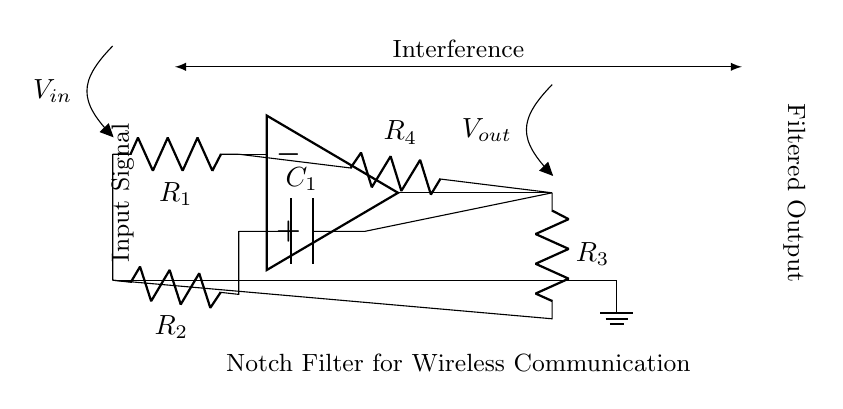What is the type of this filter? The circuit is specified as a Notch Filter, which is indicated in the diagram label. Its purpose is to eliminate particular frequencies of interference.
Answer: Notch Filter How many resistors are in the circuit? By counting the components in the diagram, there are four resistors labeled R1, R2, R3, and R4.
Answer: Four What is the function of the operational amplifier? The operational amplifier amplifies the input signal and helps in creating the required filter characteristics to remove unwanted noise.
Answer: Amplification What does C1 represent? C1 is labeled as a capacitor in the circuit, which stores electrical energy and impacts the frequency response of the notch filter.
Answer: Capacitor What is the output signal labeled as? The output signal is indicated in the diagram as Vout, showing the filtered result after interference removal.
Answer: Vout What is the effect of the resistor R4? Resistor R4 is part of the feedback loop for the operational amplifier, influencing the gain and bandwidth of the filter, which determines how effectively it can reject certain frequencies.
Answer: Gain Control What does the arrow between the input and output signals depict? The arrow signifies the direction of signal flow, indicating that the input signal is processed to produce the output after filtering.
Answer: Signal Flow 